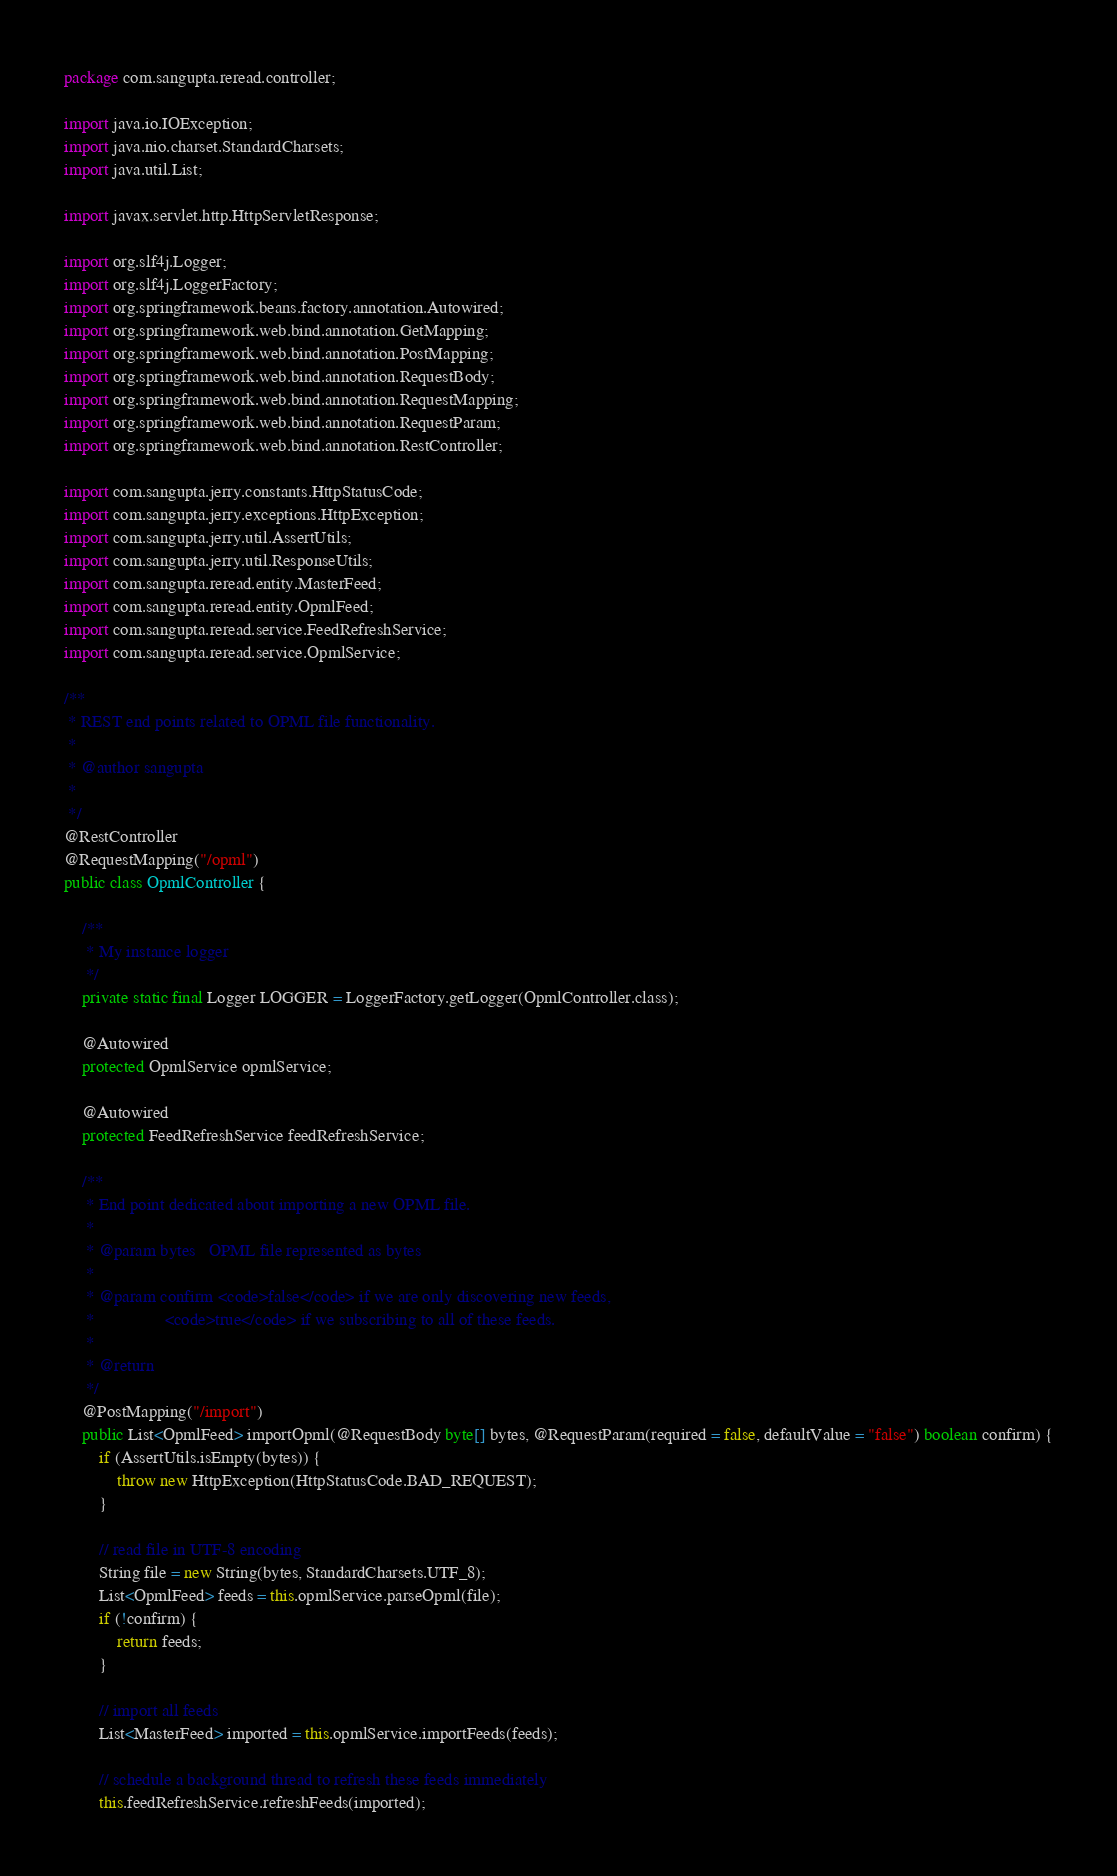<code> <loc_0><loc_0><loc_500><loc_500><_Java_>package com.sangupta.reread.controller;

import java.io.IOException;
import java.nio.charset.StandardCharsets;
import java.util.List;

import javax.servlet.http.HttpServletResponse;

import org.slf4j.Logger;
import org.slf4j.LoggerFactory;
import org.springframework.beans.factory.annotation.Autowired;
import org.springframework.web.bind.annotation.GetMapping;
import org.springframework.web.bind.annotation.PostMapping;
import org.springframework.web.bind.annotation.RequestBody;
import org.springframework.web.bind.annotation.RequestMapping;
import org.springframework.web.bind.annotation.RequestParam;
import org.springframework.web.bind.annotation.RestController;

import com.sangupta.jerry.constants.HttpStatusCode;
import com.sangupta.jerry.exceptions.HttpException;
import com.sangupta.jerry.util.AssertUtils;
import com.sangupta.jerry.util.ResponseUtils;
import com.sangupta.reread.entity.MasterFeed;
import com.sangupta.reread.entity.OpmlFeed;
import com.sangupta.reread.service.FeedRefreshService;
import com.sangupta.reread.service.OpmlService;

/**
 * REST end points related to OPML file functionality.
 * 
 * @author sangupta
 *
 */
@RestController
@RequestMapping("/opml")
public class OpmlController {

	/**
	 * My instance logger
	 */
	private static final Logger LOGGER = LoggerFactory.getLogger(OpmlController.class);

	@Autowired
	protected OpmlService opmlService;

	@Autowired
	protected FeedRefreshService feedRefreshService;
	
	/**
	 * End point dedicated about importing a new OPML file.
	 * 
	 * @param bytes   OPML file represented as bytes
	 * 
	 * @param confirm <code>false</code> if we are only discovering new feeds,
	 *                <code>true</code> if we subscribing to all of these feeds.
	 * 
	 * @return
	 */
	@PostMapping("/import")
	public List<OpmlFeed> importOpml(@RequestBody byte[] bytes, @RequestParam(required = false, defaultValue = "false") boolean confirm) {
		if (AssertUtils.isEmpty(bytes)) {
			throw new HttpException(HttpStatusCode.BAD_REQUEST);
		}

		// read file in UTF-8 encoding
		String file = new String(bytes, StandardCharsets.UTF_8);
		List<OpmlFeed> feeds = this.opmlService.parseOpml(file);
		if (!confirm) {
			return feeds;
		}

		// import all feeds
		List<MasterFeed> imported = this.opmlService.importFeeds(feeds);

		// schedule a background thread to refresh these feeds immediately
		this.feedRefreshService.refreshFeeds(imported);
</code> 